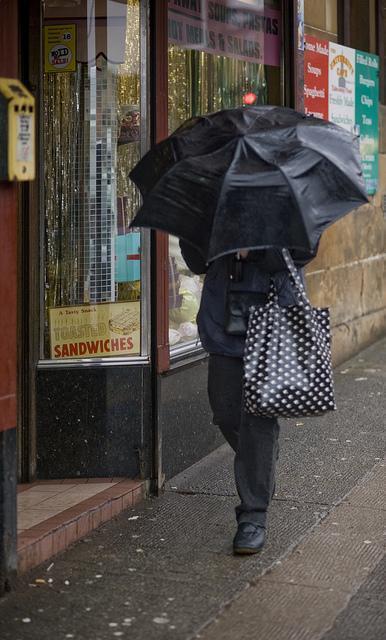How many umbrellas are there?
Give a very brief answer. 1. 